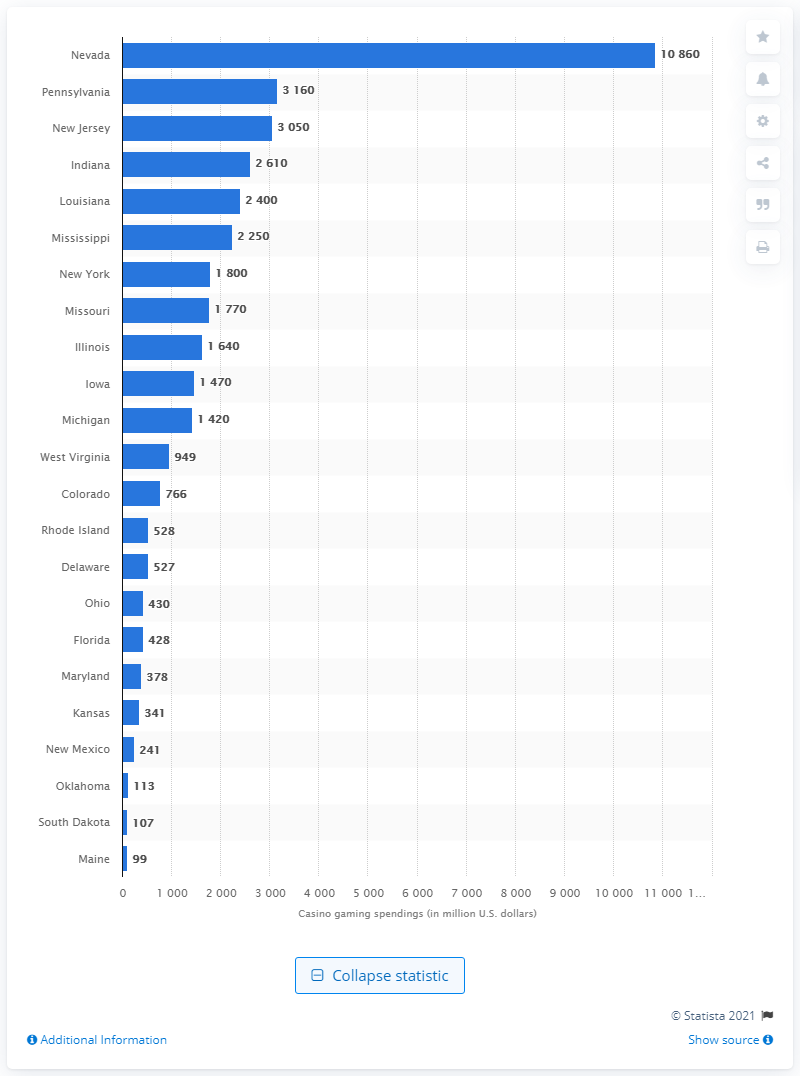Draw attention to some important aspects in this diagram. The amount that Colorado consumers spent on casino gaming in 2012 was $766 million. 